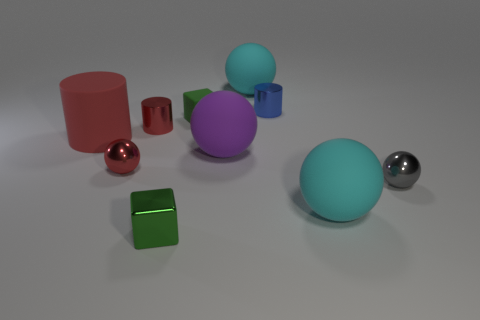How many small green metal things have the same shape as the big red thing?
Your answer should be compact. 0. Does the small matte cube have the same color as the metal block?
Your answer should be very brief. Yes. Are there fewer rubber spheres than matte cylinders?
Offer a terse response. No. There is a green block behind the purple ball; what material is it?
Provide a short and direct response. Rubber. What is the material of the cylinder that is the same size as the purple sphere?
Offer a terse response. Rubber. There is a cylinder that is on the right side of the small green cube on the right side of the green object that is in front of the red metal ball; what is it made of?
Ensure brevity in your answer.  Metal. There is a blue metallic cylinder that is behind the purple sphere; is it the same size as the gray object?
Provide a succinct answer. Yes. Is the number of blue shiny cylinders greater than the number of cyan rubber balls?
Ensure brevity in your answer.  No. What number of large things are either cylinders or rubber cylinders?
Make the answer very short. 1. How many other objects are there of the same color as the large cylinder?
Offer a very short reply. 2. 